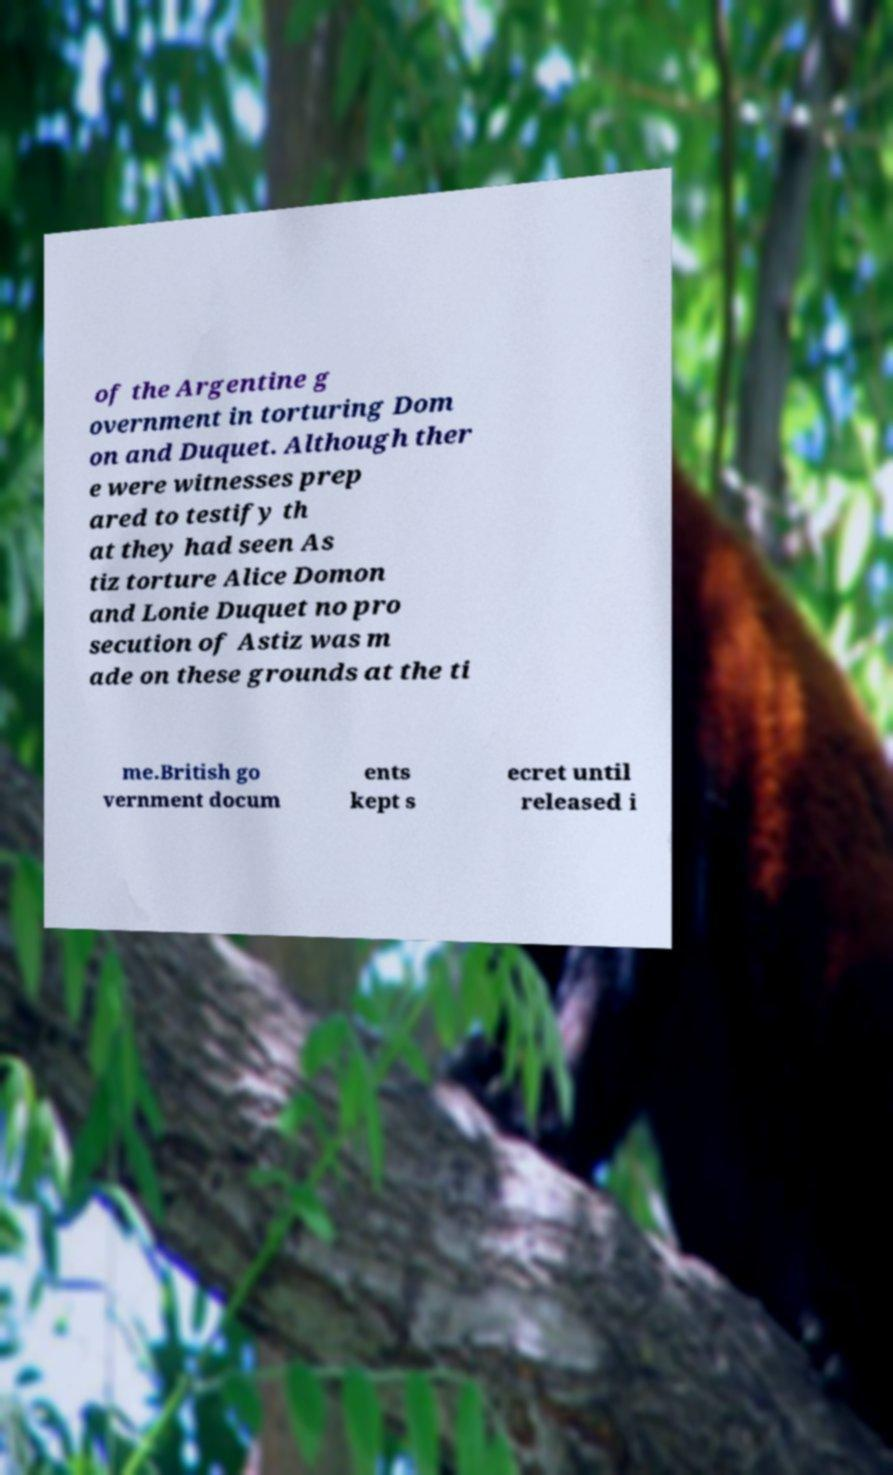Please identify and transcribe the text found in this image. of the Argentine g overnment in torturing Dom on and Duquet. Although ther e were witnesses prep ared to testify th at they had seen As tiz torture Alice Domon and Lonie Duquet no pro secution of Astiz was m ade on these grounds at the ti me.British go vernment docum ents kept s ecret until released i 